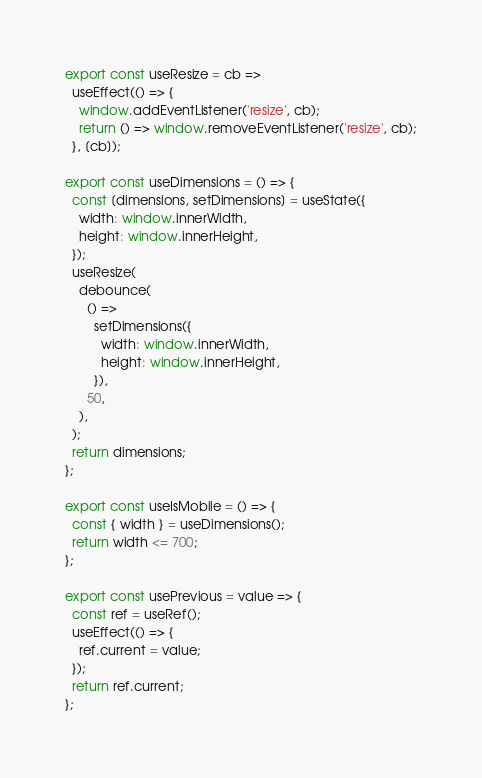<code> <loc_0><loc_0><loc_500><loc_500><_JavaScript_>
export const useResize = cb =>
  useEffect(() => {
    window.addEventListener('resize', cb);
    return () => window.removeEventListener('resize', cb);
  }, [cb]);

export const useDimensions = () => {
  const [dimensions, setDimensions] = useState({
    width: window.innerWidth,
    height: window.innerHeight,
  });
  useResize(
    debounce(
      () =>
        setDimensions({
          width: window.innerWidth,
          height: window.innerHeight,
        }),
      50,
    ),
  );
  return dimensions;
};

export const useIsMobile = () => {
  const { width } = useDimensions();
  return width <= 700;
};

export const usePrevious = value => {
  const ref = useRef();
  useEffect(() => {
    ref.current = value;
  });
  return ref.current;
};
</code> 